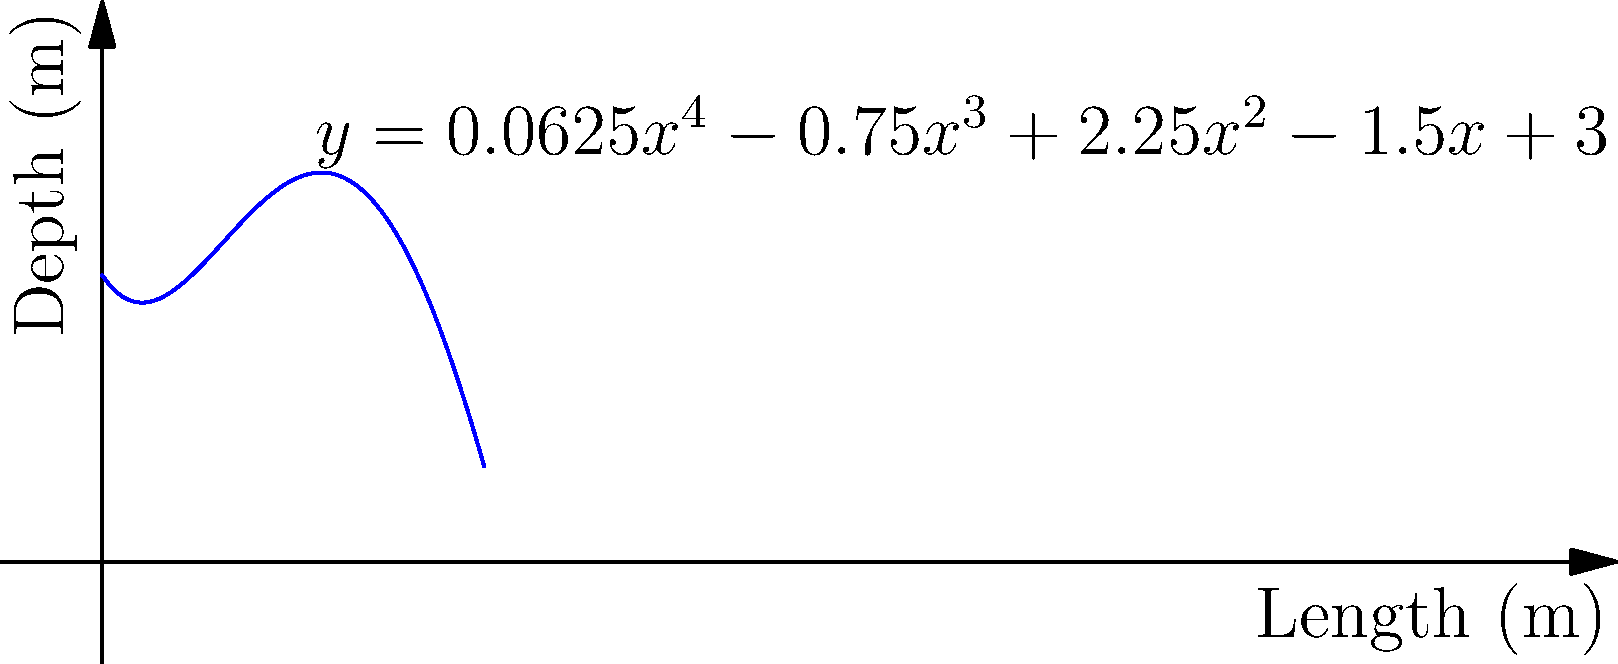As a professional swimmer, you're analyzing the depth profile of a new swimming pool. The depth $y$ (in meters) of the pool at a distance $x$ (in meters) from one end is modeled by the quartic function:

$$y = 0.0625x^4 - 0.75x^3 + 2.25x^2 - 1.5x + 3$$

Where is the deepest point of the pool located, and what is its depth? To find the deepest point of the pool, we need to determine the maximum value of the function within the domain of the pool's length.

Step 1: Find the derivative of the function.
$$y' = 0.25x^3 - 2.25x^2 + 4.5x - 1.5$$

Step 2: Set the derivative equal to zero and solve for x.
$$0.25x^3 - 2.25x^2 + 4.5x - 1.5 = 0$$

This is a cubic equation. While it can be solved algebraically, it's complex. Using a graphing calculator or computer algebra system, we find the solutions:

$x ≈ 0.37, 2, 3.63$

Step 3: Evaluate the second derivative at these points to determine which one is a maximum.
$$y'' = 0.75x^2 - 4.5x + 4.5$$

At $x = 2$, $y'' < 0$, indicating a local maximum.

Step 4: Calculate the depth at $x = 2$.
$$y = 0.0625(2)^4 - 0.75(2)^3 + 2.25(2)^2 - 1.5(2) + 3 = 4$$

Therefore, the deepest point is located 2 meters from one end of the pool, with a depth of 4 meters.
Answer: 2 meters from one end, 4 meters deep 